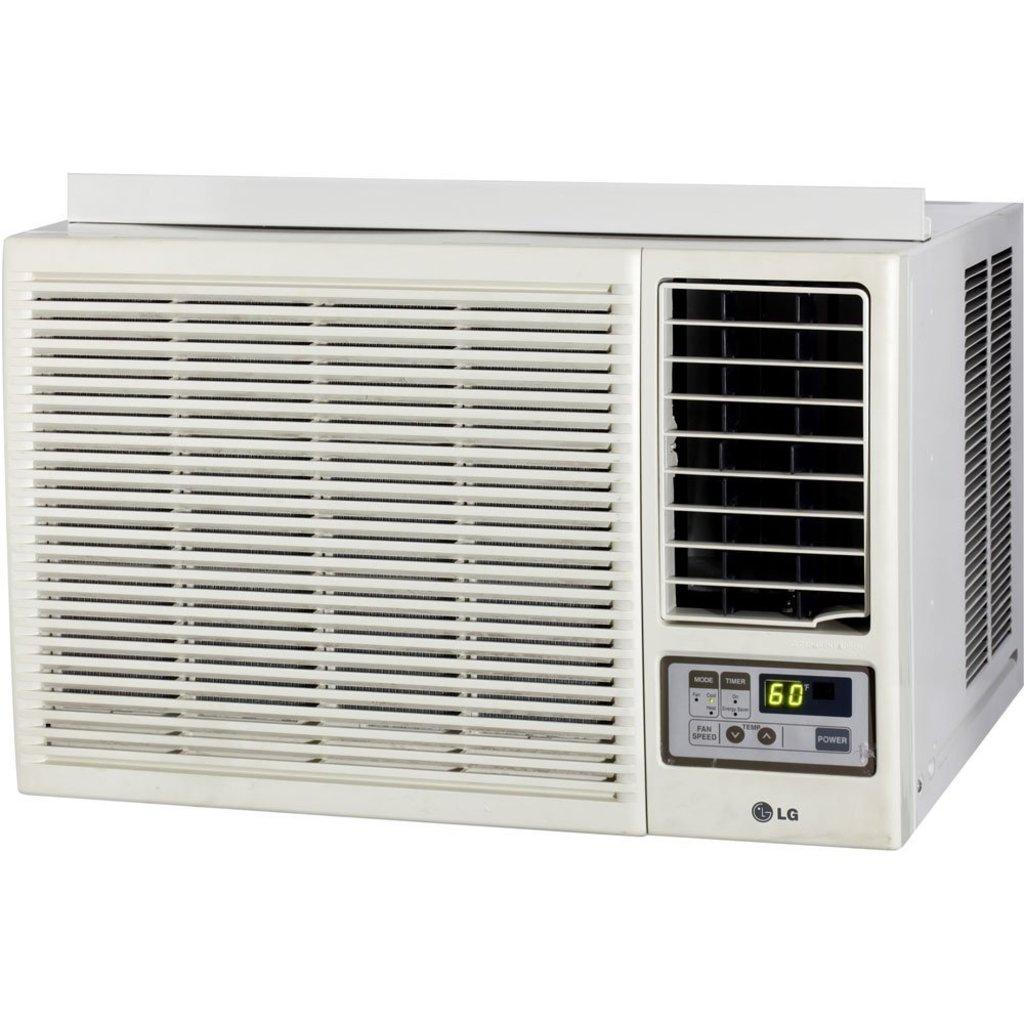What is the color of the machine in the image? The machine in the image is white. What can be seen in the background of the image? The background of the image is white. What type of glue is being used to attach the plastic to the roof in the image? There is no glue, plastic, or roof present in the image. 